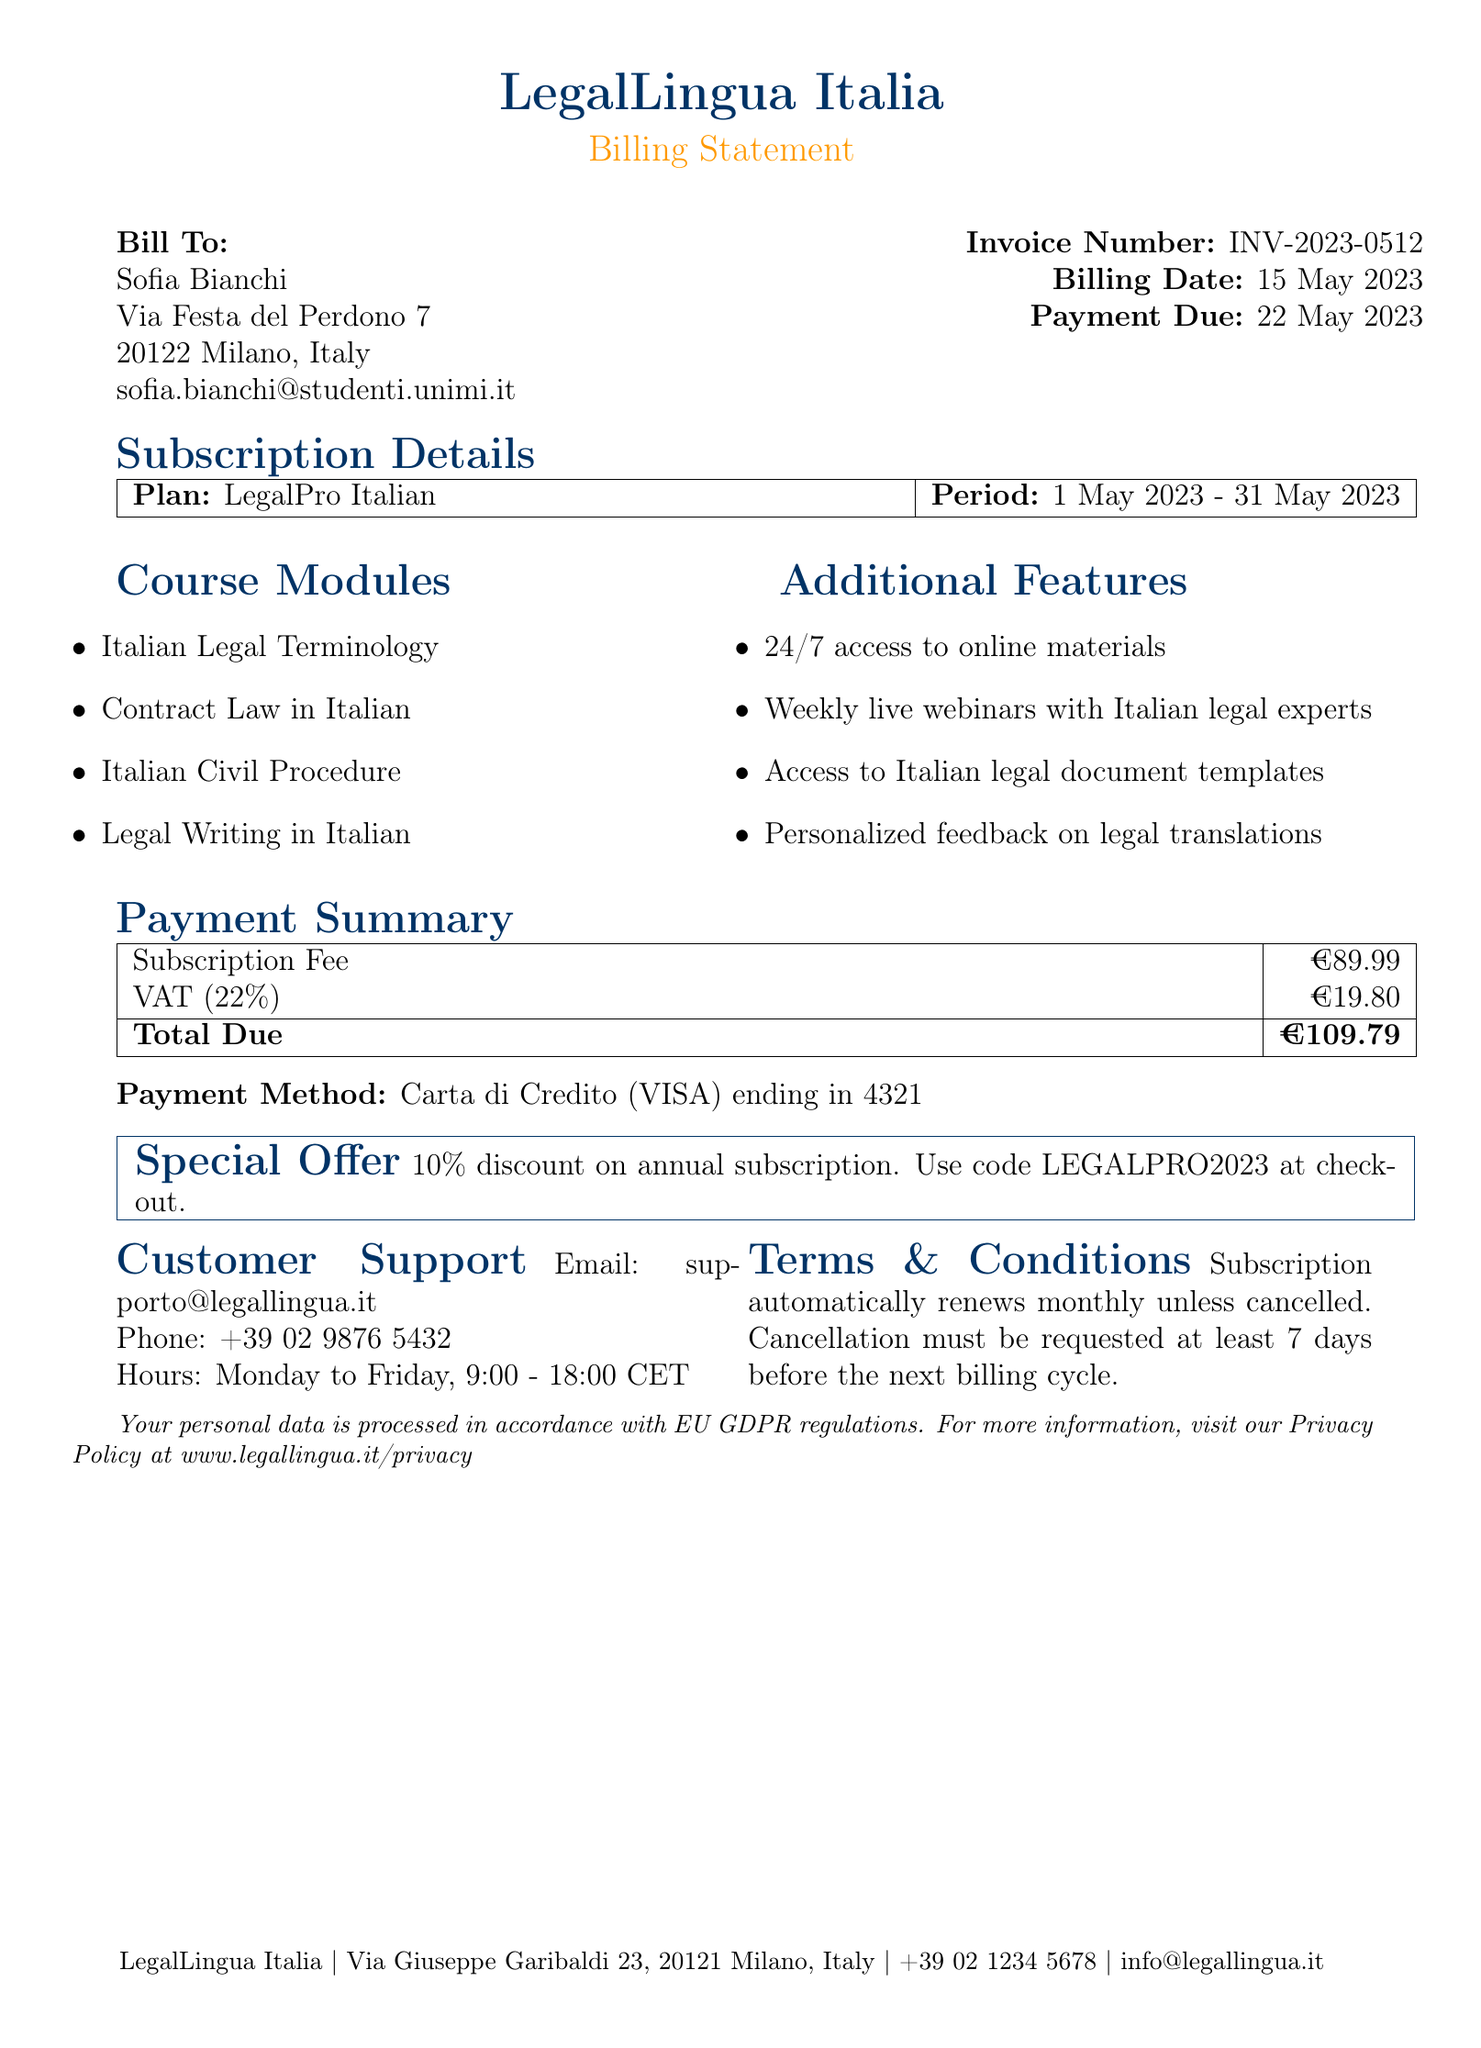What is the name of the company? The company's name is presented at the top of the document.
Answer: LegalLingua Italia What is the customer’s email address? The email address of the customer is listed under their details.
Answer: sofia.bianchi@studenti.unimi.it What is the billing date? The date when the billing statement was issued is noted in the document.
Answer: 15 May 2023 What is the duration of the subscription period? The subscription period indicates the start and end dates for the billing cycle.
Answer: 1 May 2023 - 31 May 2023 What is the total amount due? The total amount due is calculated after adding the subscription fee and VAT.
Answer: €109.79 What VAT rate is applied? The VAT rate is indicated in the payment summary section of the document.
Answer: 22% What is the payment method used? The document specifies how the payment will be made.
Answer: Carta di Credito (VISA) ending in 4321 How can a customer contact support? The contact information for customer support is provided in the document.
Answer: supporto@legallingua.it What is one of the special offers mentioned? The document includes a promotional offer related to subscriptions.
Answer: 10% discount on annual subscription 